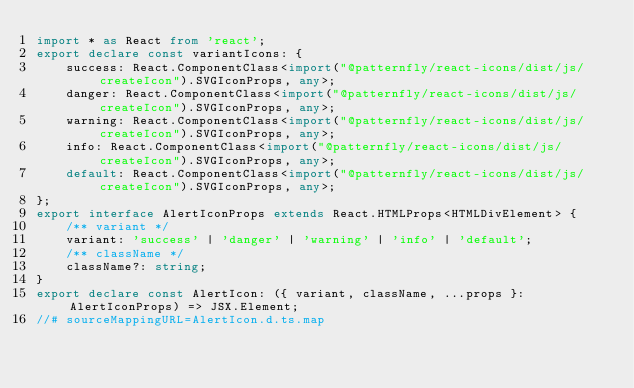Convert code to text. <code><loc_0><loc_0><loc_500><loc_500><_TypeScript_>import * as React from 'react';
export declare const variantIcons: {
    success: React.ComponentClass<import("@patternfly/react-icons/dist/js/createIcon").SVGIconProps, any>;
    danger: React.ComponentClass<import("@patternfly/react-icons/dist/js/createIcon").SVGIconProps, any>;
    warning: React.ComponentClass<import("@patternfly/react-icons/dist/js/createIcon").SVGIconProps, any>;
    info: React.ComponentClass<import("@patternfly/react-icons/dist/js/createIcon").SVGIconProps, any>;
    default: React.ComponentClass<import("@patternfly/react-icons/dist/js/createIcon").SVGIconProps, any>;
};
export interface AlertIconProps extends React.HTMLProps<HTMLDivElement> {
    /** variant */
    variant: 'success' | 'danger' | 'warning' | 'info' | 'default';
    /** className */
    className?: string;
}
export declare const AlertIcon: ({ variant, className, ...props }: AlertIconProps) => JSX.Element;
//# sourceMappingURL=AlertIcon.d.ts.map</code> 